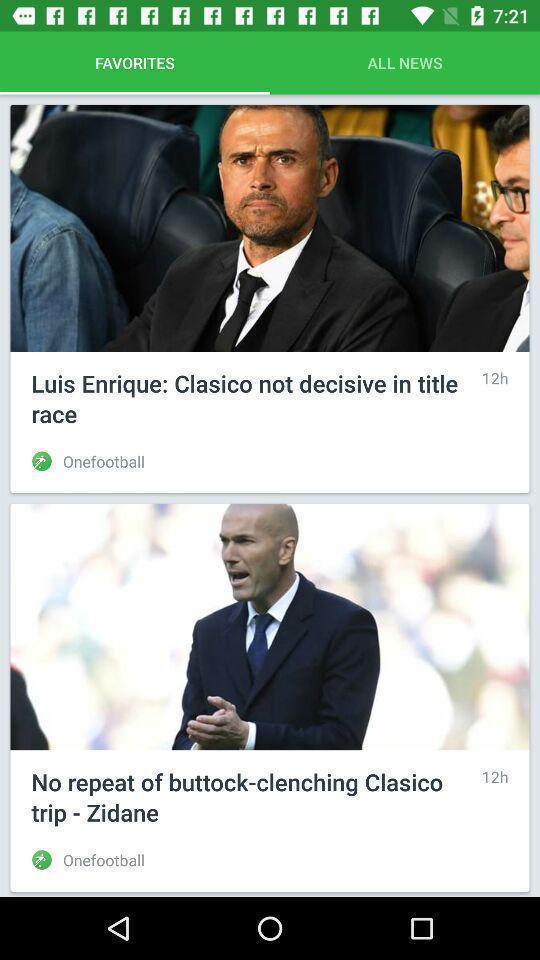Describe the visual elements of this screenshot. Screen displaying favorites page of a news app. 